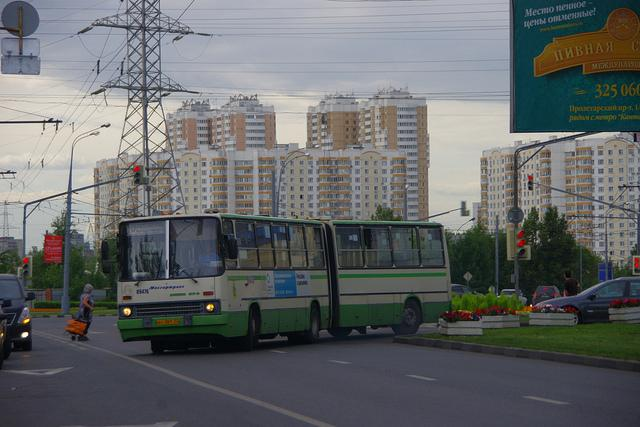What is the woman trying to do? cross street 